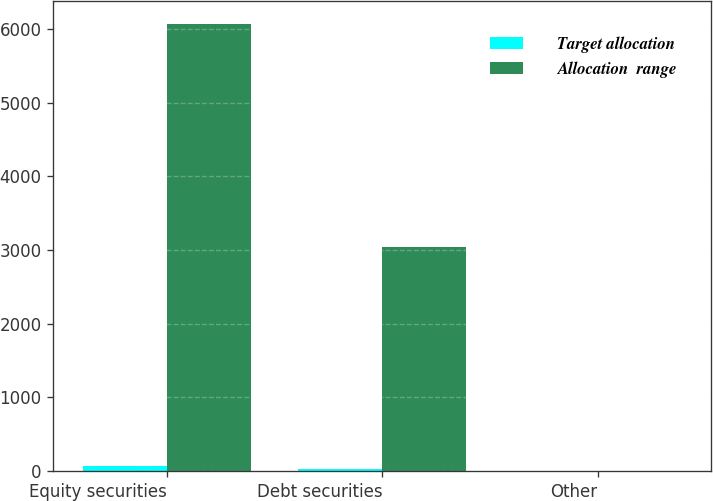Convert chart to OTSL. <chart><loc_0><loc_0><loc_500><loc_500><stacked_bar_chart><ecel><fcel>Equity securities<fcel>Debt securities<fcel>Other<nl><fcel>Target allocation<fcel>65<fcel>35<fcel>0<nl><fcel>Allocation  range<fcel>6070<fcel>3040<fcel>5<nl></chart> 